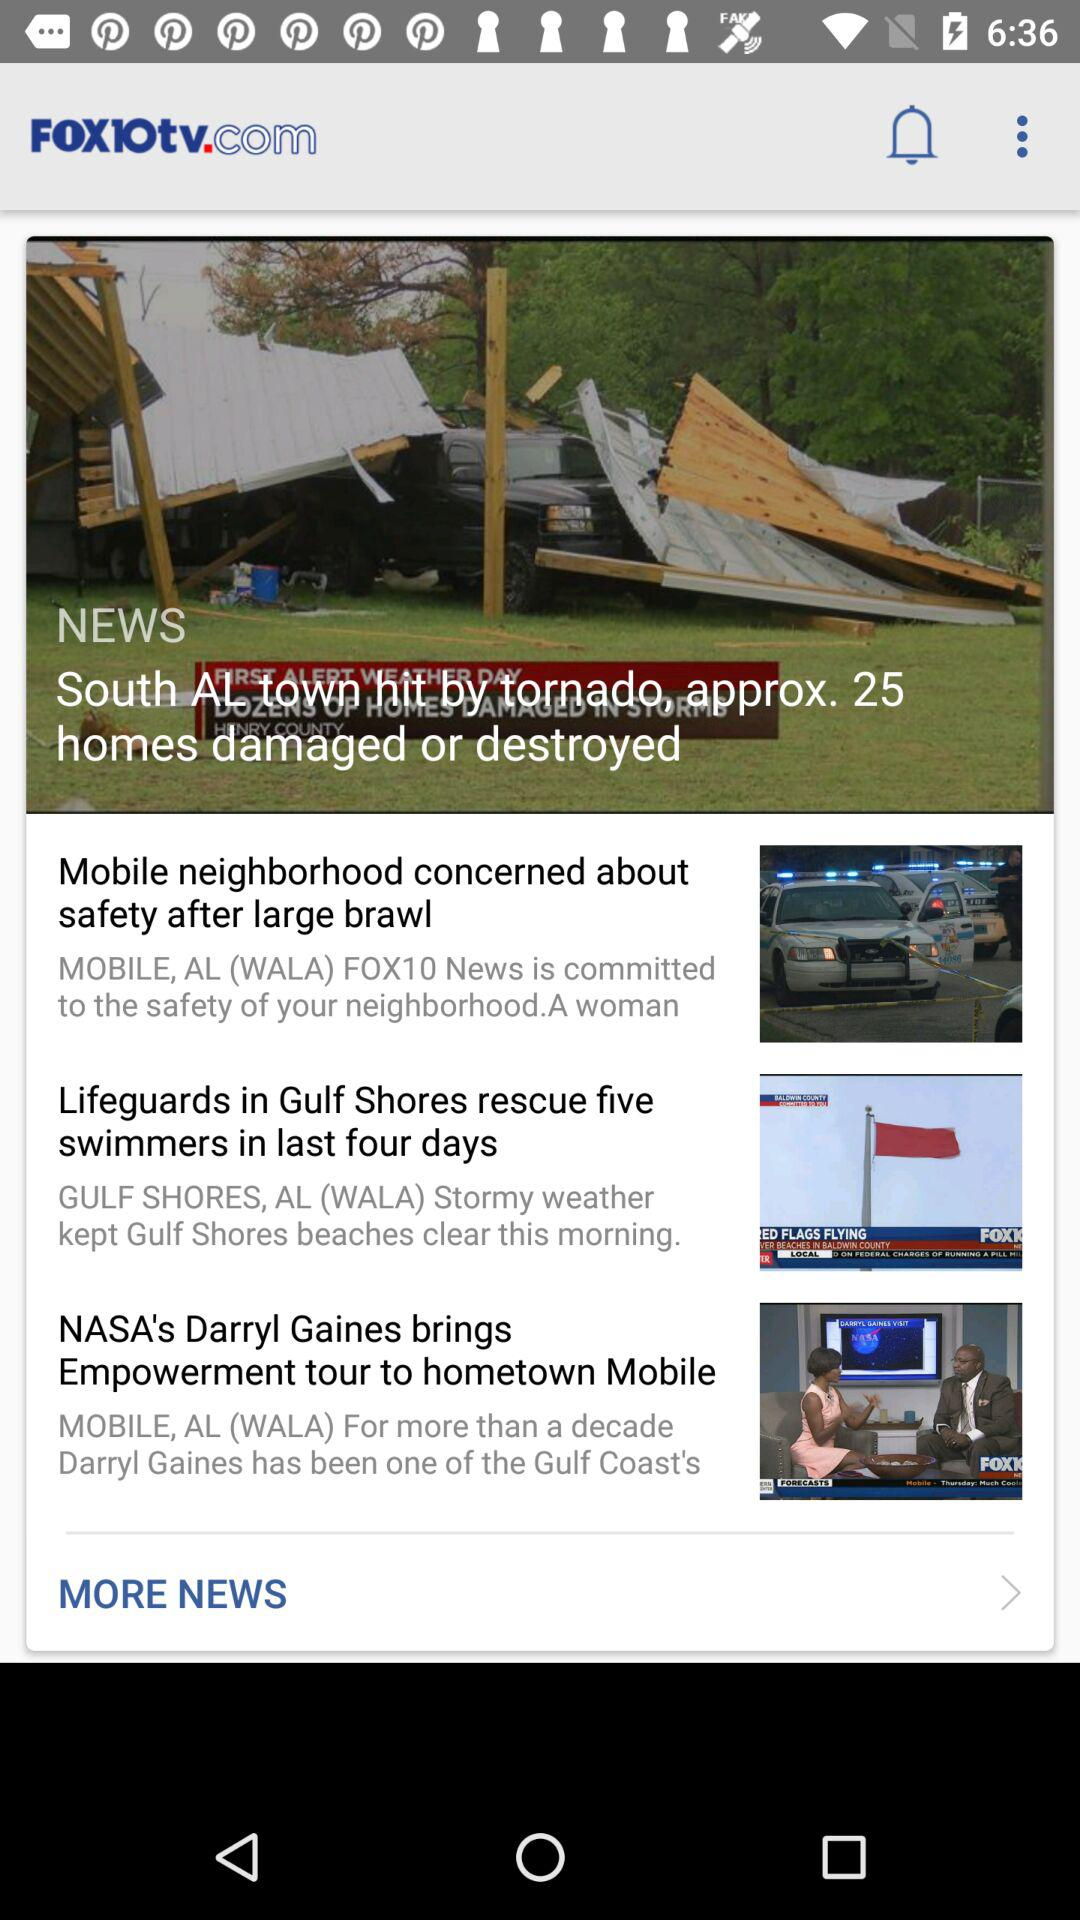What is the application name? The application name is "FOX10tv.com". 